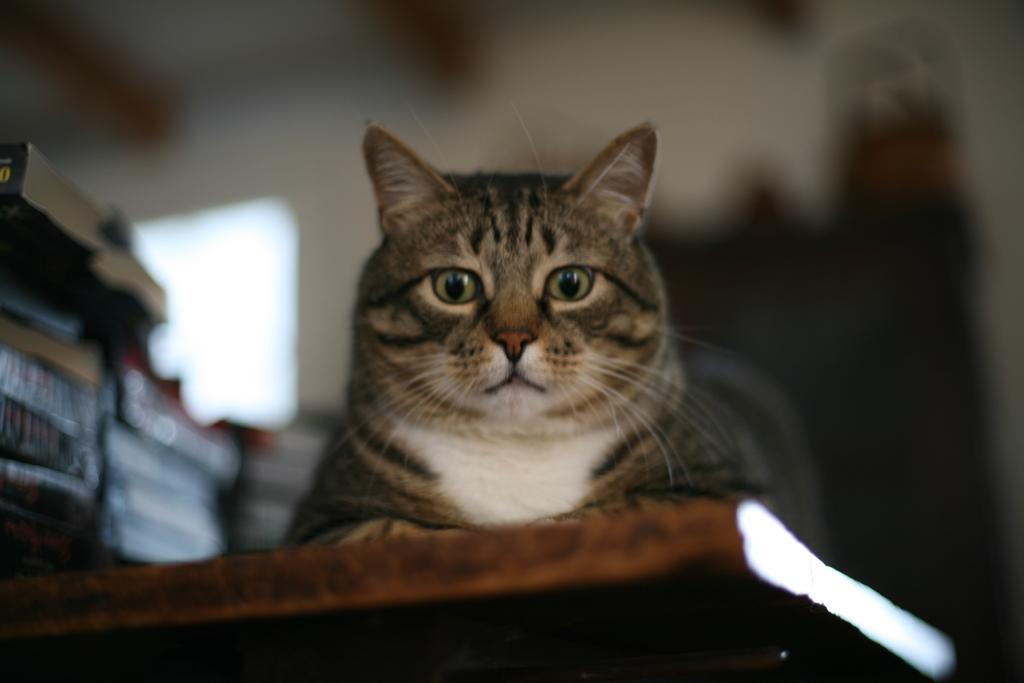What animal is present in the image? There is a cat in the image. What type of surface is the cat on? The cat is on a wooden surface. What can be seen in the background of the image? There are books, a wall, and unspecified objects in the background of the image. What type of vegetable is being used as a spoon by the dinosaurs in the image? There are no dinosaurs or vegetables present in the image, and therefore no such activity can be observed. 